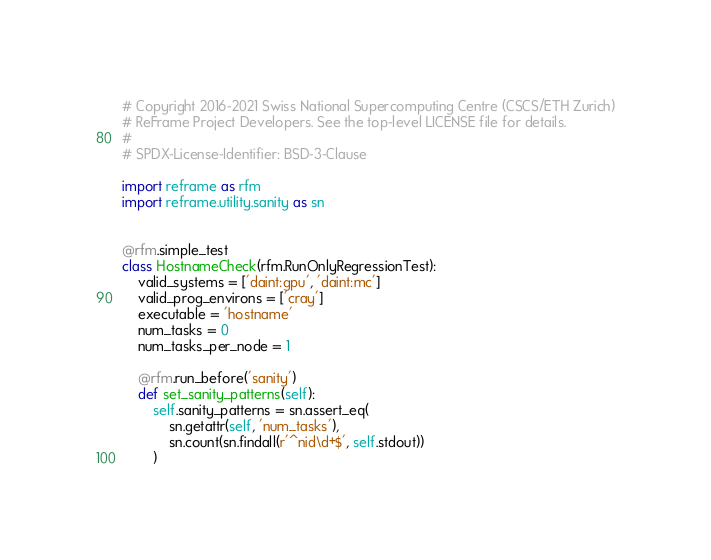<code> <loc_0><loc_0><loc_500><loc_500><_Python_># Copyright 2016-2021 Swiss National Supercomputing Centre (CSCS/ETH Zurich)
# ReFrame Project Developers. See the top-level LICENSE file for details.
#
# SPDX-License-Identifier: BSD-3-Clause

import reframe as rfm
import reframe.utility.sanity as sn


@rfm.simple_test
class HostnameCheck(rfm.RunOnlyRegressionTest):
    valid_systems = ['daint:gpu', 'daint:mc']
    valid_prog_environs = ['cray']
    executable = 'hostname'
    num_tasks = 0
    num_tasks_per_node = 1

    @rfm.run_before('sanity')
    def set_sanity_patterns(self):
        self.sanity_patterns = sn.assert_eq(
            sn.getattr(self, 'num_tasks'),
            sn.count(sn.findall(r'^nid\d+$', self.stdout))
        )
</code> 